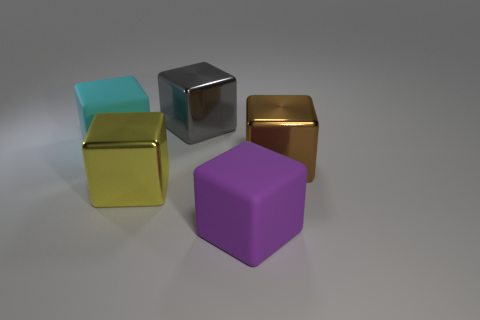What is the purple thing made of?
Give a very brief answer. Rubber. There is a gray object that is the same shape as the cyan matte thing; what is its material?
Offer a very short reply. Metal. There is a rubber thing that is on the right side of the big metallic thing that is behind the cyan cube; what is its color?
Give a very brief answer. Purple. What number of metal things are either large gray blocks or purple cylinders?
Make the answer very short. 1. Are the big purple thing and the large brown cube made of the same material?
Offer a terse response. No. The large cube on the right side of the big rubber block that is in front of the cyan object is made of what material?
Offer a terse response. Metal. How many big objects are either shiny things or cyan matte things?
Ensure brevity in your answer.  4. What is the size of the cyan thing?
Give a very brief answer. Large. Is the number of large brown metallic things that are in front of the brown cube greater than the number of big blue rubber things?
Keep it short and to the point. No. Are there the same number of big purple objects in front of the big yellow metal block and metal things that are behind the large purple rubber cube?
Your answer should be compact. No. 